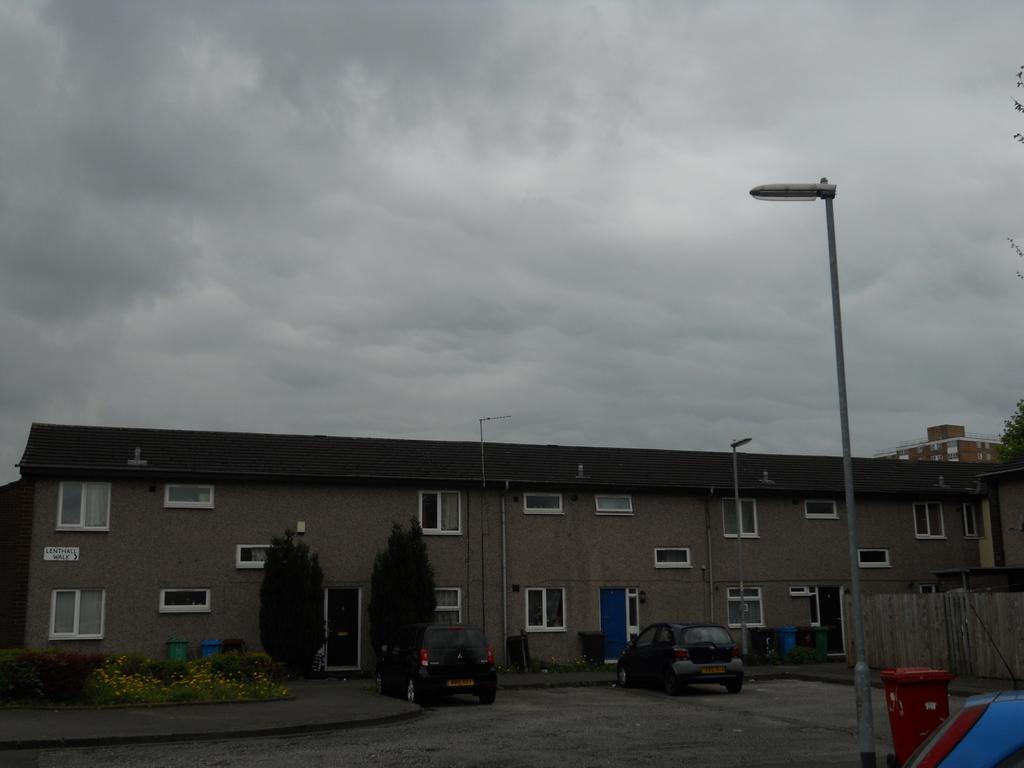Could you give a brief overview of what you see in this image? In this image in the center there is a building, trees, plants, vehicles and there is a pole and street light. And in the bottom right hand corner there are containers, at the top there is sky and at the bottom there is walkway. 